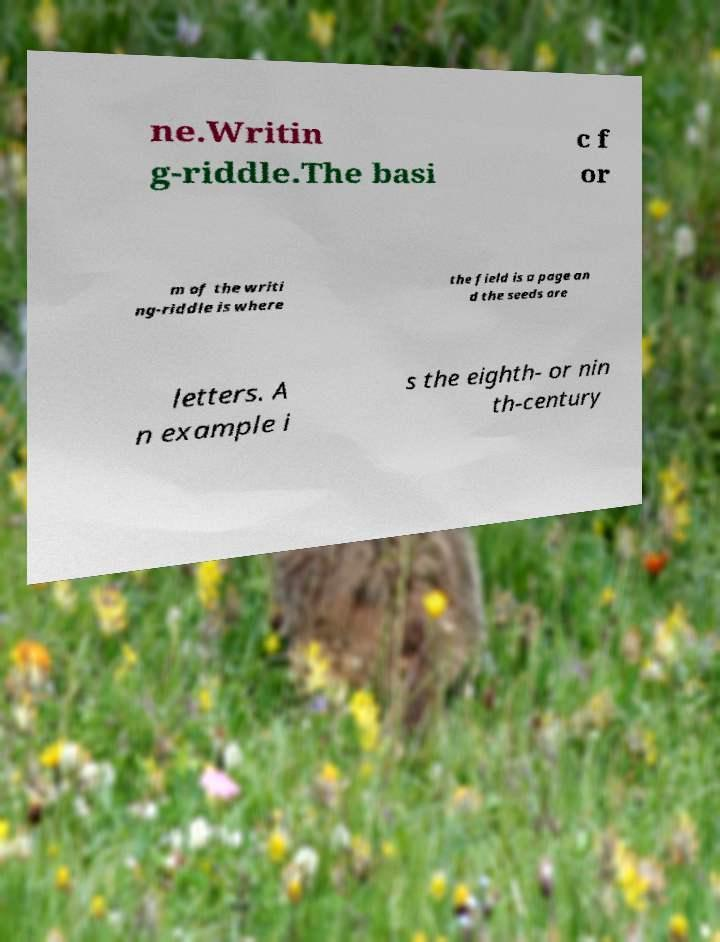Could you assist in decoding the text presented in this image and type it out clearly? ne.Writin g-riddle.The basi c f or m of the writi ng-riddle is where the field is a page an d the seeds are letters. A n example i s the eighth- or nin th-century 